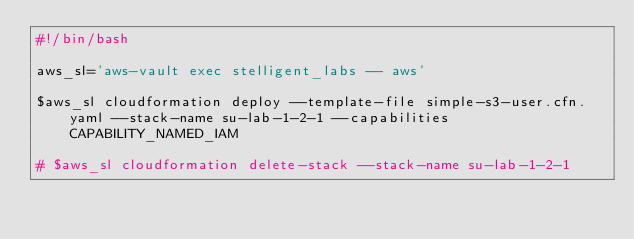Convert code to text. <code><loc_0><loc_0><loc_500><loc_500><_Bash_>#!/bin/bash

aws_sl='aws-vault exec stelligent_labs -- aws'

$aws_sl cloudformation deploy --template-file simple-s3-user.cfn.yaml --stack-name su-lab-1-2-1 --capabilities CAPABILITY_NAMED_IAM

# $aws_sl cloudformation delete-stack --stack-name su-lab-1-2-1</code> 